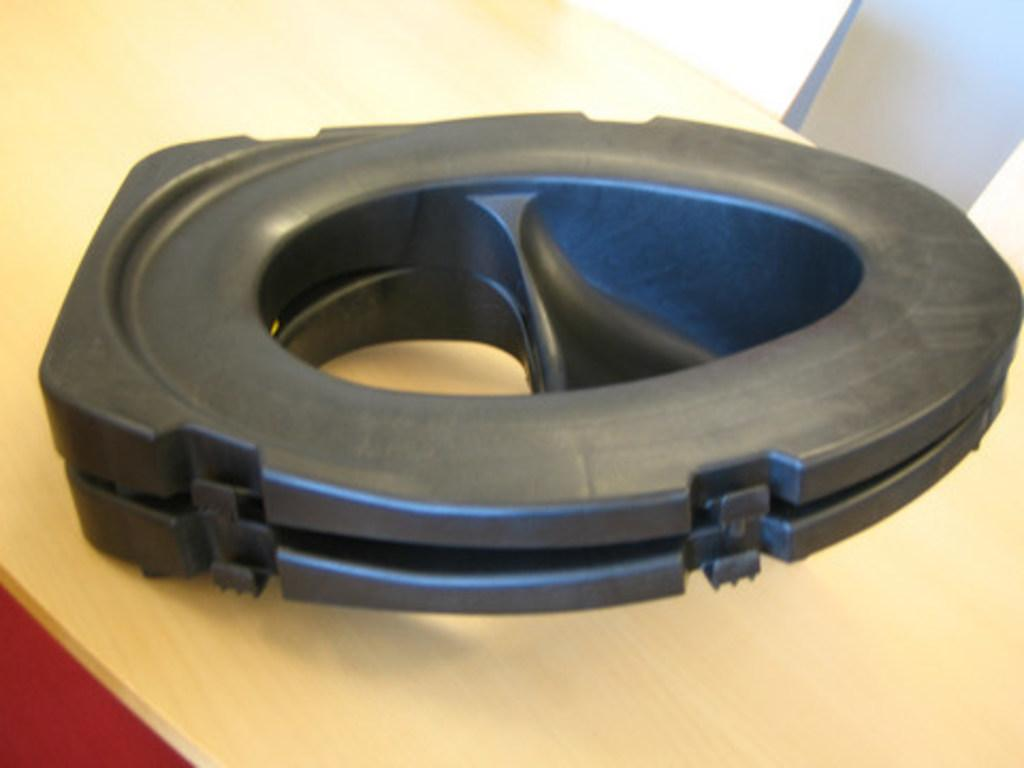What is the main object in the image? There is a black object that looks like a subwoofer in the image. Where is the subwoofer located? The subwoofer is placed on a table. What can be seen in the right top of the image? There is a white pillar in the right top of the image. What type of committee is meeting in the image? There is no committee meeting in the image; it only features a subwoofer on a table and a white pillar in the right top. Can you see a box containing the airplane in the image? There is no box or airplane present in the image. 